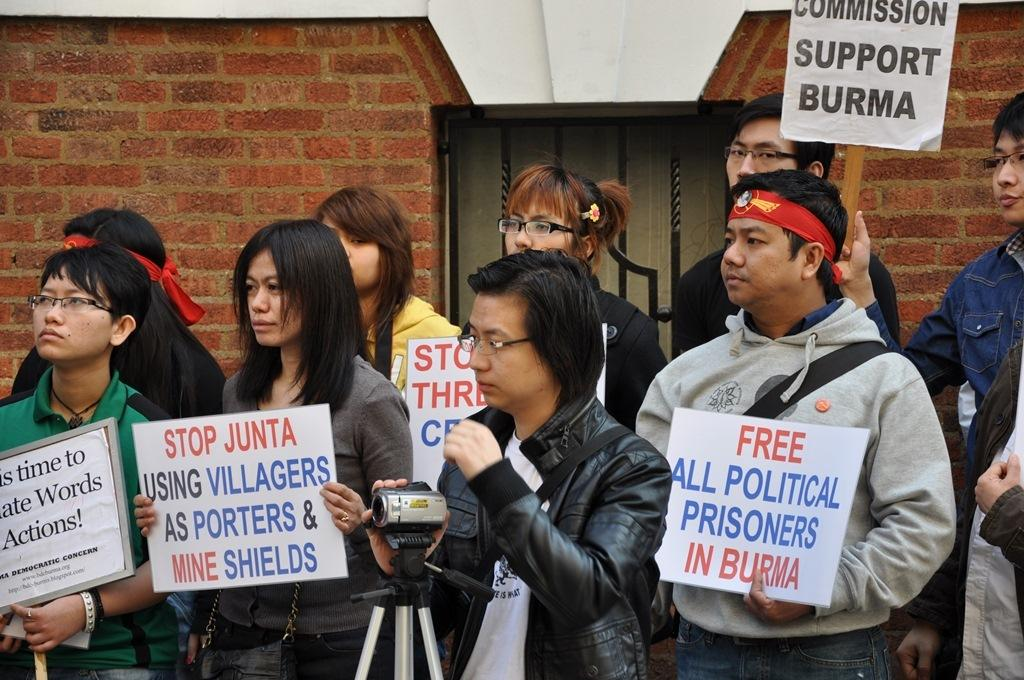What types of people are in the image? There are men and women in the image. Where are the people located in the image? They are standing in the front. What are the people holding in the image? They are holding a banner. Can you describe the person in the middle? There is a man in the middle holding a camera. What can be seen in the background of the image? There is a brick wall in the background, and it has a window in the middle. What type of letters can be seen on the elbow of the person in the image? There are no letters visible on anyone's elbow in the image. What type of brake can be seen on the banner in the image? There is no brake present in the image; it features a banner being held by the people. 